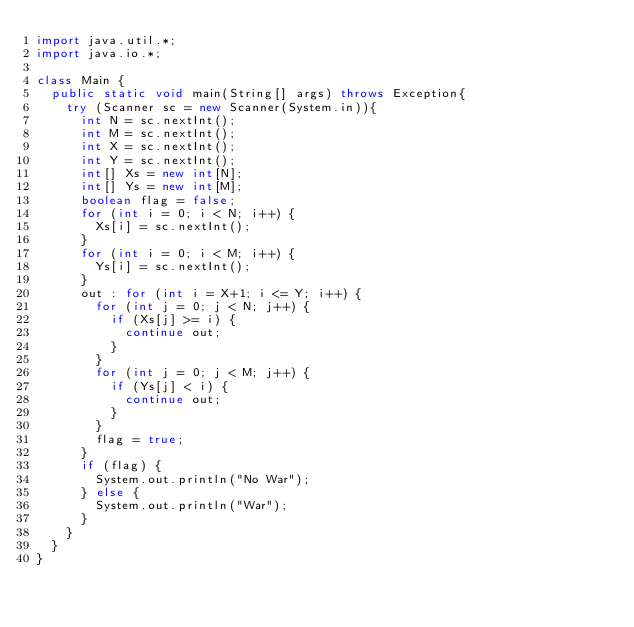<code> <loc_0><loc_0><loc_500><loc_500><_Java_>import java.util.*;
import java.io.*;

class Main {
  public static void main(String[] args) throws Exception{
    try (Scanner sc = new Scanner(System.in)){
      int N = sc.nextInt();
      int M = sc.nextInt();
      int X = sc.nextInt();
      int Y = sc.nextInt();
      int[] Xs = new int[N];
      int[] Ys = new int[M];
      boolean flag = false;
      for (int i = 0; i < N; i++) {
        Xs[i] = sc.nextInt();
      }
      for (int i = 0; i < M; i++) {
        Ys[i] = sc.nextInt();
      }
      out : for (int i = X+1; i <= Y; i++) {
        for (int j = 0; j < N; j++) {
          if (Xs[j] >= i) {
            continue out;
          }
        }
        for (int j = 0; j < M; j++) {
          if (Ys[j] < i) {
            continue out;
          }
        }
        flag = true;
      }
      if (flag) {
        System.out.println("No War");
      } else {
        System.out.println("War");
      }
    }
  }
}
</code> 